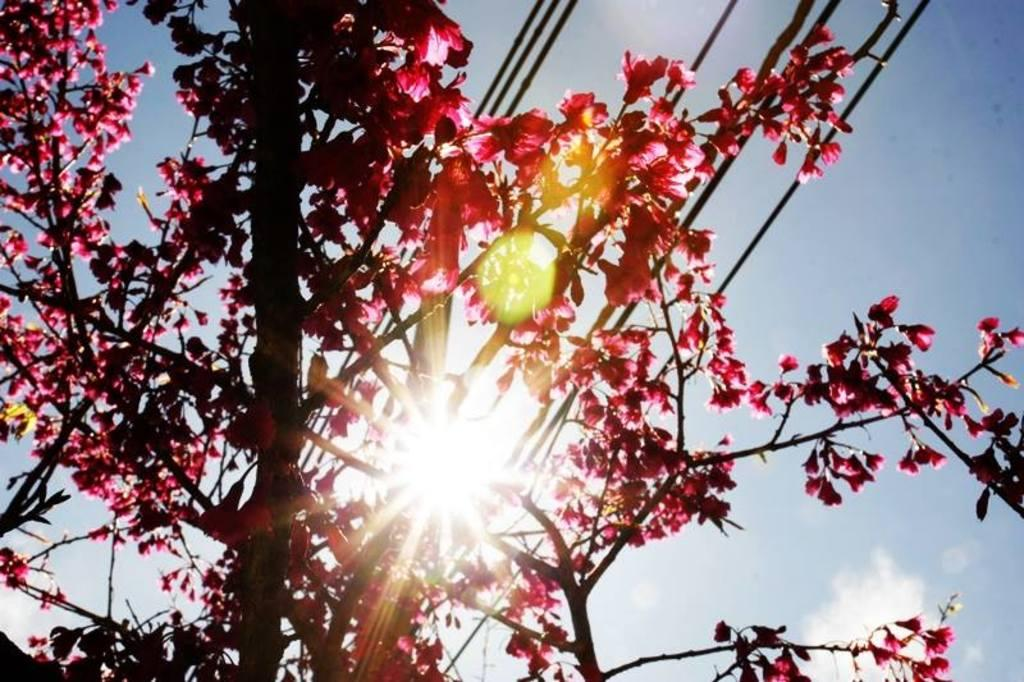What event is taking place in the image? The image depicts a sunrise. What can be seen in the background of the image? There are trees, flowers, wires, and clouds visible in the background of the image. What type of cheese is being cooked on the stove in the image? There is no cheese or stove present in the image; it features a sunrise with trees, flowers, wires, and clouds in the background. 